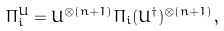Convert formula to latex. <formula><loc_0><loc_0><loc_500><loc_500>\Pi ^ { U } _ { i } = U ^ { \otimes ( n + 1 ) } \Pi _ { i } ( U ^ { \dagger } ) ^ { \otimes ( n + 1 ) } ,</formula> 